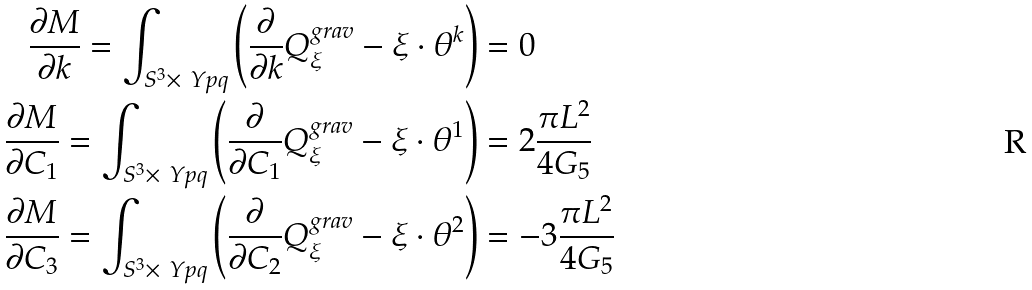<formula> <loc_0><loc_0><loc_500><loc_500>\frac { \partial M } { \partial k } = \int _ { S ^ { 3 } \times \ Y p q } \left ( \frac { \partial } { \partial k } Q _ { \xi } ^ { g r a v } - \xi \cdot \theta ^ { k } \right ) & = 0 \\ \frac { \partial M } { \partial C _ { 1 } } = \int _ { S ^ { 3 } \times \ Y p q } \left ( \frac { \partial } { \partial C _ { 1 } } Q _ { \xi } ^ { g r a v } - \xi \cdot \theta ^ { 1 } \right ) & = 2 \frac { \pi L ^ { 2 } } { 4 G _ { 5 } } \\ \frac { \partial M } { \partial C _ { 3 } } = \int _ { S ^ { 3 } \times \ Y p q } \left ( \frac { \partial } { \partial C _ { 2 } } Q _ { \xi } ^ { g r a v } - \xi \cdot \theta ^ { 2 } \right ) & = - 3 \frac { \pi L ^ { 2 } } { 4 G _ { 5 } }</formula> 